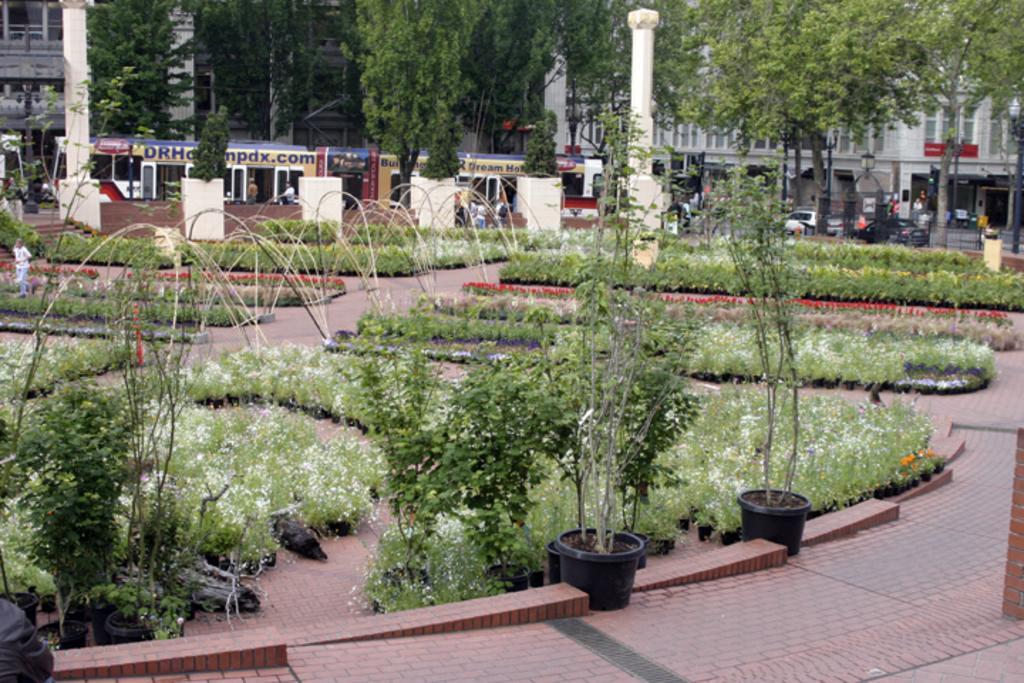How would you summarize this image in a sentence or two? In this picture there are few plants and plant pots and there are few vehicles,buildings and trees in the background. 